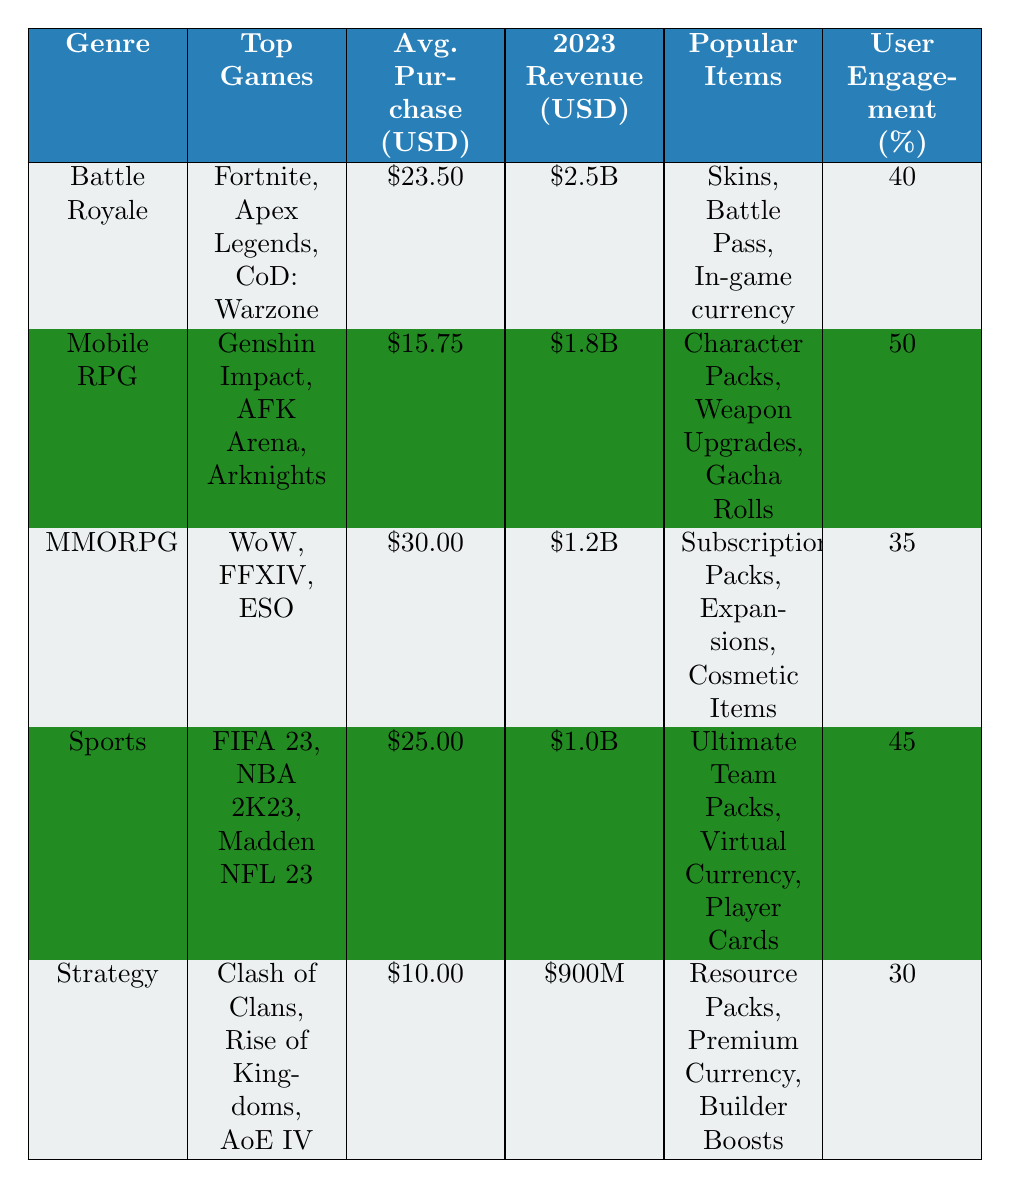What is the total revenue generated by the Battle Royale genre? The Battle Royale genre has a total revenue of $2.5 billion as stated in the table.
Answer: $2.5 billion Which genre has the highest average purchase value? The MMORPG genre has the highest average purchase value, which is $30.00.
Answer: $30.00 How many different games are listed under the Mobile RPG genre? There are three games listed under Mobile RPG: Genshin Impact, AFK Arena, and Arknights.
Answer: Three Is the user engagement percentage higher for Strategy games than for Battle Royale games? The Strategy genre has a user engagement of 30%, while the Battle Royale genre has an engagement of 40%. Since 30% is less than 40%, the statement is false.
Answer: No What is the difference between the total revenue of Mobile RPG and MMORPG? Mobile RPG's total revenue is $1.8 billion and MMORPG's total revenue is $1.2 billion. The difference is $1.8 billion - $1.2 billion = $0.6 billion.
Answer: $0.6 billion How many genres have an average purchase value above $20? The genres with average purchase values above $20 are Battle Royale ($23.50), MMORPG ($30.00), and Sports ($25.00), totaling three genres.
Answer: Three Which popular items are common in the Battle Royale and Sports genres? The popular items in Battle Royale include Skins, Battle Pass, and In-game currency, while in Sports, they are Ultimate Team Packs, Virtual Currency, and Player Cards. There are no common items listed between the two genres based on the table.
Answer: No What is the average user engagement percentage across all genres? The average user engagement is calculated by adding the percentages: (40 + 50 + 35 + 45 + 30) = 200, then dividing by the number of genres (5). Thus, the average is 200/5 = 40%.
Answer: 40% 